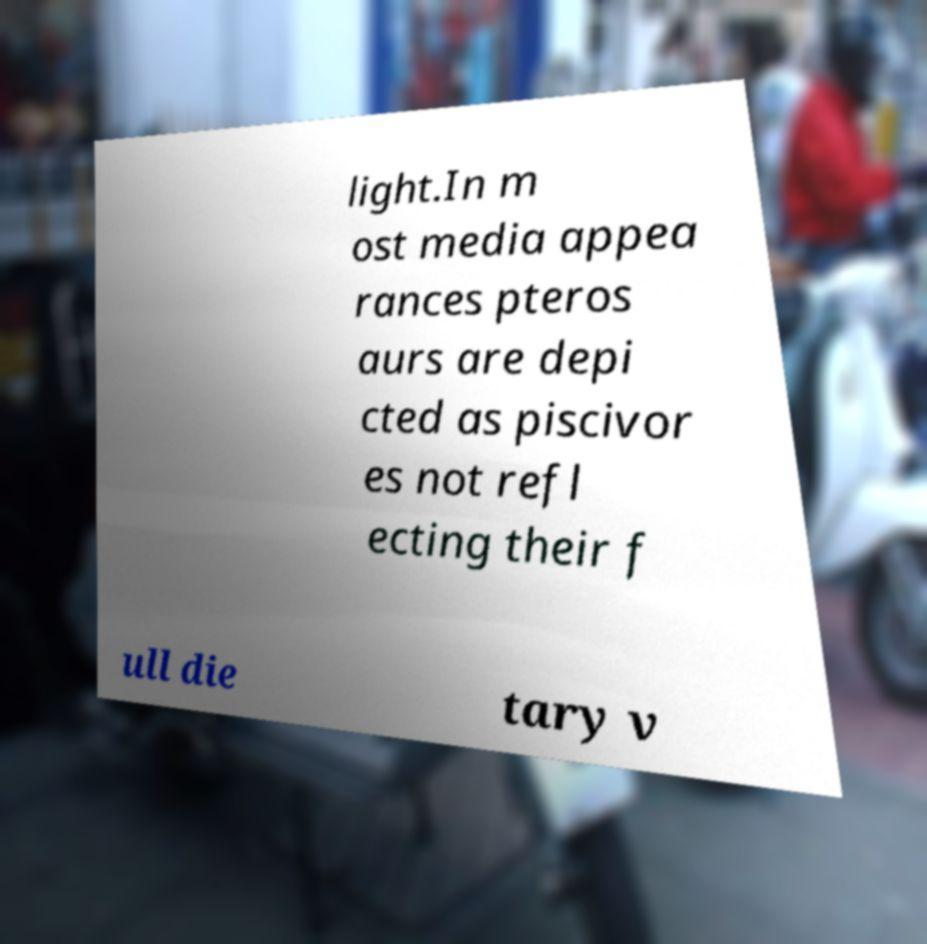For documentation purposes, I need the text within this image transcribed. Could you provide that? light.In m ost media appea rances pteros aurs are depi cted as piscivor es not refl ecting their f ull die tary v 